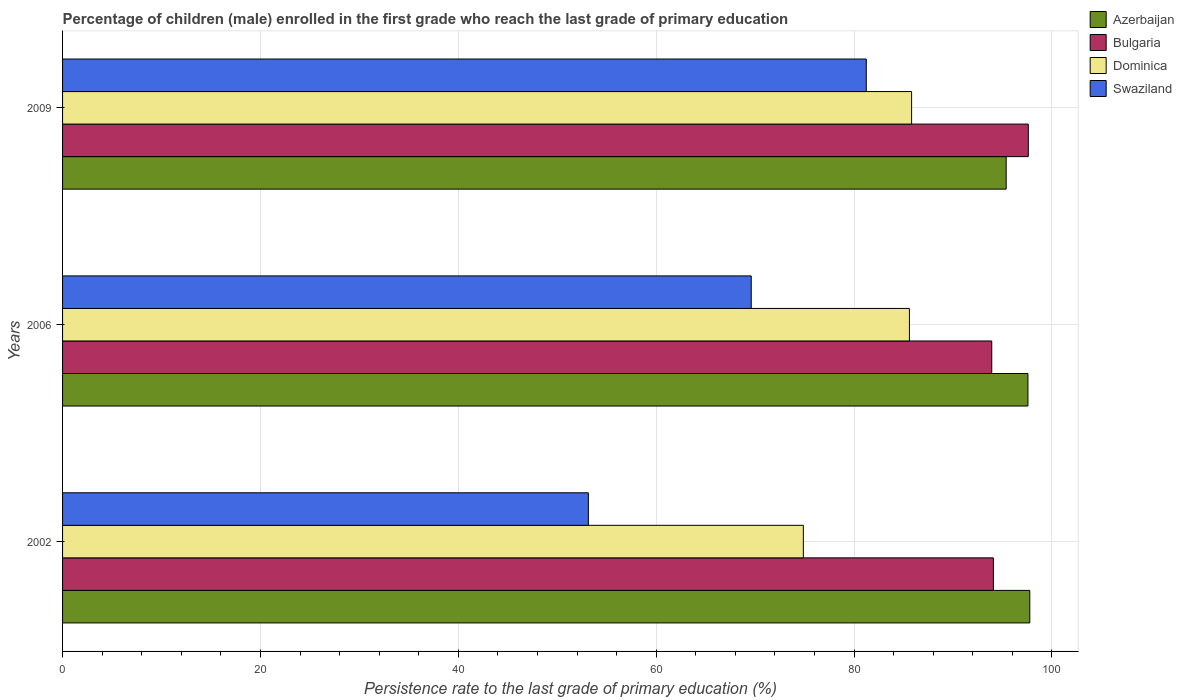How many different coloured bars are there?
Your answer should be very brief. 4. Are the number of bars on each tick of the Y-axis equal?
Make the answer very short. Yes. How many bars are there on the 2nd tick from the bottom?
Provide a succinct answer. 4. In how many cases, is the number of bars for a given year not equal to the number of legend labels?
Make the answer very short. 0. What is the persistence rate of children in Dominica in 2002?
Give a very brief answer. 74.88. Across all years, what is the maximum persistence rate of children in Dominica?
Offer a terse response. 85.82. Across all years, what is the minimum persistence rate of children in Bulgaria?
Provide a short and direct response. 93.92. In which year was the persistence rate of children in Dominica minimum?
Your response must be concise. 2002. What is the total persistence rate of children in Swaziland in the graph?
Your answer should be compact. 204. What is the difference between the persistence rate of children in Bulgaria in 2006 and that in 2009?
Your answer should be very brief. -3.7. What is the difference between the persistence rate of children in Swaziland in 2006 and the persistence rate of children in Azerbaijan in 2002?
Your answer should be very brief. -28.16. What is the average persistence rate of children in Azerbaijan per year?
Give a very brief answer. 96.91. In the year 2002, what is the difference between the persistence rate of children in Swaziland and persistence rate of children in Bulgaria?
Keep it short and to the point. -40.94. In how many years, is the persistence rate of children in Swaziland greater than 64 %?
Make the answer very short. 2. What is the ratio of the persistence rate of children in Dominica in 2002 to that in 2009?
Give a very brief answer. 0.87. Is the persistence rate of children in Dominica in 2002 less than that in 2009?
Your answer should be compact. Yes. What is the difference between the highest and the second highest persistence rate of children in Bulgaria?
Make the answer very short. 3.53. What is the difference between the highest and the lowest persistence rate of children in Dominica?
Keep it short and to the point. 10.94. Is the sum of the persistence rate of children in Bulgaria in 2002 and 2009 greater than the maximum persistence rate of children in Swaziland across all years?
Your answer should be compact. Yes. Is it the case that in every year, the sum of the persistence rate of children in Swaziland and persistence rate of children in Azerbaijan is greater than the sum of persistence rate of children in Bulgaria and persistence rate of children in Dominica?
Your answer should be compact. No. What does the 1st bar from the top in 2006 represents?
Offer a very short reply. Swaziland. What does the 3rd bar from the bottom in 2002 represents?
Offer a very short reply. Dominica. How many bars are there?
Your response must be concise. 12. What is the difference between two consecutive major ticks on the X-axis?
Offer a terse response. 20. What is the title of the graph?
Give a very brief answer. Percentage of children (male) enrolled in the first grade who reach the last grade of primary education. What is the label or title of the X-axis?
Give a very brief answer. Persistence rate to the last grade of primary education (%). What is the label or title of the Y-axis?
Ensure brevity in your answer.  Years. What is the Persistence rate to the last grade of primary education (%) of Azerbaijan in 2002?
Keep it short and to the point. 97.77. What is the Persistence rate to the last grade of primary education (%) of Bulgaria in 2002?
Provide a succinct answer. 94.09. What is the Persistence rate to the last grade of primary education (%) in Dominica in 2002?
Ensure brevity in your answer.  74.88. What is the Persistence rate to the last grade of primary education (%) in Swaziland in 2002?
Your answer should be compact. 53.15. What is the Persistence rate to the last grade of primary education (%) of Azerbaijan in 2006?
Your answer should be compact. 97.58. What is the Persistence rate to the last grade of primary education (%) of Bulgaria in 2006?
Your answer should be compact. 93.92. What is the Persistence rate to the last grade of primary education (%) of Dominica in 2006?
Offer a terse response. 85.6. What is the Persistence rate to the last grade of primary education (%) in Swaziland in 2006?
Give a very brief answer. 69.61. What is the Persistence rate to the last grade of primary education (%) in Azerbaijan in 2009?
Offer a very short reply. 95.38. What is the Persistence rate to the last grade of primary education (%) of Bulgaria in 2009?
Provide a succinct answer. 97.62. What is the Persistence rate to the last grade of primary education (%) of Dominica in 2009?
Your answer should be compact. 85.82. What is the Persistence rate to the last grade of primary education (%) in Swaziland in 2009?
Offer a terse response. 81.24. Across all years, what is the maximum Persistence rate to the last grade of primary education (%) in Azerbaijan?
Offer a very short reply. 97.77. Across all years, what is the maximum Persistence rate to the last grade of primary education (%) of Bulgaria?
Keep it short and to the point. 97.62. Across all years, what is the maximum Persistence rate to the last grade of primary education (%) in Dominica?
Provide a short and direct response. 85.82. Across all years, what is the maximum Persistence rate to the last grade of primary education (%) in Swaziland?
Your answer should be compact. 81.24. Across all years, what is the minimum Persistence rate to the last grade of primary education (%) of Azerbaijan?
Your response must be concise. 95.38. Across all years, what is the minimum Persistence rate to the last grade of primary education (%) in Bulgaria?
Provide a short and direct response. 93.92. Across all years, what is the minimum Persistence rate to the last grade of primary education (%) in Dominica?
Offer a terse response. 74.88. Across all years, what is the minimum Persistence rate to the last grade of primary education (%) in Swaziland?
Your response must be concise. 53.15. What is the total Persistence rate to the last grade of primary education (%) of Azerbaijan in the graph?
Ensure brevity in your answer.  290.73. What is the total Persistence rate to the last grade of primary education (%) of Bulgaria in the graph?
Provide a short and direct response. 285.62. What is the total Persistence rate to the last grade of primary education (%) in Dominica in the graph?
Your answer should be very brief. 246.3. What is the total Persistence rate to the last grade of primary education (%) of Swaziland in the graph?
Your answer should be compact. 204. What is the difference between the Persistence rate to the last grade of primary education (%) of Azerbaijan in 2002 and that in 2006?
Provide a succinct answer. 0.19. What is the difference between the Persistence rate to the last grade of primary education (%) in Bulgaria in 2002 and that in 2006?
Offer a terse response. 0.16. What is the difference between the Persistence rate to the last grade of primary education (%) in Dominica in 2002 and that in 2006?
Make the answer very short. -10.72. What is the difference between the Persistence rate to the last grade of primary education (%) in Swaziland in 2002 and that in 2006?
Provide a succinct answer. -16.46. What is the difference between the Persistence rate to the last grade of primary education (%) of Azerbaijan in 2002 and that in 2009?
Ensure brevity in your answer.  2.39. What is the difference between the Persistence rate to the last grade of primary education (%) in Bulgaria in 2002 and that in 2009?
Your answer should be very brief. -3.53. What is the difference between the Persistence rate to the last grade of primary education (%) of Dominica in 2002 and that in 2009?
Make the answer very short. -10.94. What is the difference between the Persistence rate to the last grade of primary education (%) of Swaziland in 2002 and that in 2009?
Give a very brief answer. -28.09. What is the difference between the Persistence rate to the last grade of primary education (%) in Azerbaijan in 2006 and that in 2009?
Make the answer very short. 2.2. What is the difference between the Persistence rate to the last grade of primary education (%) in Bulgaria in 2006 and that in 2009?
Your answer should be compact. -3.7. What is the difference between the Persistence rate to the last grade of primary education (%) in Dominica in 2006 and that in 2009?
Offer a very short reply. -0.22. What is the difference between the Persistence rate to the last grade of primary education (%) of Swaziland in 2006 and that in 2009?
Offer a very short reply. -11.63. What is the difference between the Persistence rate to the last grade of primary education (%) of Azerbaijan in 2002 and the Persistence rate to the last grade of primary education (%) of Bulgaria in 2006?
Your response must be concise. 3.85. What is the difference between the Persistence rate to the last grade of primary education (%) in Azerbaijan in 2002 and the Persistence rate to the last grade of primary education (%) in Dominica in 2006?
Ensure brevity in your answer.  12.17. What is the difference between the Persistence rate to the last grade of primary education (%) in Azerbaijan in 2002 and the Persistence rate to the last grade of primary education (%) in Swaziland in 2006?
Offer a terse response. 28.16. What is the difference between the Persistence rate to the last grade of primary education (%) of Bulgaria in 2002 and the Persistence rate to the last grade of primary education (%) of Dominica in 2006?
Offer a terse response. 8.49. What is the difference between the Persistence rate to the last grade of primary education (%) of Bulgaria in 2002 and the Persistence rate to the last grade of primary education (%) of Swaziland in 2006?
Offer a very short reply. 24.48. What is the difference between the Persistence rate to the last grade of primary education (%) in Dominica in 2002 and the Persistence rate to the last grade of primary education (%) in Swaziland in 2006?
Your response must be concise. 5.27. What is the difference between the Persistence rate to the last grade of primary education (%) in Azerbaijan in 2002 and the Persistence rate to the last grade of primary education (%) in Bulgaria in 2009?
Give a very brief answer. 0.15. What is the difference between the Persistence rate to the last grade of primary education (%) of Azerbaijan in 2002 and the Persistence rate to the last grade of primary education (%) of Dominica in 2009?
Your answer should be very brief. 11.95. What is the difference between the Persistence rate to the last grade of primary education (%) in Azerbaijan in 2002 and the Persistence rate to the last grade of primary education (%) in Swaziland in 2009?
Your answer should be very brief. 16.53. What is the difference between the Persistence rate to the last grade of primary education (%) of Bulgaria in 2002 and the Persistence rate to the last grade of primary education (%) of Dominica in 2009?
Your answer should be very brief. 8.27. What is the difference between the Persistence rate to the last grade of primary education (%) in Bulgaria in 2002 and the Persistence rate to the last grade of primary education (%) in Swaziland in 2009?
Your response must be concise. 12.85. What is the difference between the Persistence rate to the last grade of primary education (%) in Dominica in 2002 and the Persistence rate to the last grade of primary education (%) in Swaziland in 2009?
Your answer should be very brief. -6.36. What is the difference between the Persistence rate to the last grade of primary education (%) in Azerbaijan in 2006 and the Persistence rate to the last grade of primary education (%) in Bulgaria in 2009?
Provide a short and direct response. -0.04. What is the difference between the Persistence rate to the last grade of primary education (%) of Azerbaijan in 2006 and the Persistence rate to the last grade of primary education (%) of Dominica in 2009?
Offer a terse response. 11.76. What is the difference between the Persistence rate to the last grade of primary education (%) of Azerbaijan in 2006 and the Persistence rate to the last grade of primary education (%) of Swaziland in 2009?
Give a very brief answer. 16.34. What is the difference between the Persistence rate to the last grade of primary education (%) of Bulgaria in 2006 and the Persistence rate to the last grade of primary education (%) of Dominica in 2009?
Ensure brevity in your answer.  8.1. What is the difference between the Persistence rate to the last grade of primary education (%) in Bulgaria in 2006 and the Persistence rate to the last grade of primary education (%) in Swaziland in 2009?
Your response must be concise. 12.68. What is the difference between the Persistence rate to the last grade of primary education (%) of Dominica in 2006 and the Persistence rate to the last grade of primary education (%) of Swaziland in 2009?
Your answer should be very brief. 4.36. What is the average Persistence rate to the last grade of primary education (%) of Azerbaijan per year?
Your answer should be compact. 96.91. What is the average Persistence rate to the last grade of primary education (%) of Bulgaria per year?
Provide a short and direct response. 95.21. What is the average Persistence rate to the last grade of primary education (%) in Dominica per year?
Provide a succinct answer. 82.1. What is the average Persistence rate to the last grade of primary education (%) in Swaziland per year?
Provide a succinct answer. 68. In the year 2002, what is the difference between the Persistence rate to the last grade of primary education (%) of Azerbaijan and Persistence rate to the last grade of primary education (%) of Bulgaria?
Keep it short and to the point. 3.68. In the year 2002, what is the difference between the Persistence rate to the last grade of primary education (%) in Azerbaijan and Persistence rate to the last grade of primary education (%) in Dominica?
Give a very brief answer. 22.89. In the year 2002, what is the difference between the Persistence rate to the last grade of primary education (%) in Azerbaijan and Persistence rate to the last grade of primary education (%) in Swaziland?
Ensure brevity in your answer.  44.62. In the year 2002, what is the difference between the Persistence rate to the last grade of primary education (%) in Bulgaria and Persistence rate to the last grade of primary education (%) in Dominica?
Make the answer very short. 19.21. In the year 2002, what is the difference between the Persistence rate to the last grade of primary education (%) in Bulgaria and Persistence rate to the last grade of primary education (%) in Swaziland?
Provide a succinct answer. 40.94. In the year 2002, what is the difference between the Persistence rate to the last grade of primary education (%) of Dominica and Persistence rate to the last grade of primary education (%) of Swaziland?
Offer a very short reply. 21.73. In the year 2006, what is the difference between the Persistence rate to the last grade of primary education (%) in Azerbaijan and Persistence rate to the last grade of primary education (%) in Bulgaria?
Give a very brief answer. 3.66. In the year 2006, what is the difference between the Persistence rate to the last grade of primary education (%) in Azerbaijan and Persistence rate to the last grade of primary education (%) in Dominica?
Offer a very short reply. 11.98. In the year 2006, what is the difference between the Persistence rate to the last grade of primary education (%) in Azerbaijan and Persistence rate to the last grade of primary education (%) in Swaziland?
Provide a succinct answer. 27.97. In the year 2006, what is the difference between the Persistence rate to the last grade of primary education (%) in Bulgaria and Persistence rate to the last grade of primary education (%) in Dominica?
Keep it short and to the point. 8.32. In the year 2006, what is the difference between the Persistence rate to the last grade of primary education (%) of Bulgaria and Persistence rate to the last grade of primary education (%) of Swaziland?
Provide a succinct answer. 24.31. In the year 2006, what is the difference between the Persistence rate to the last grade of primary education (%) in Dominica and Persistence rate to the last grade of primary education (%) in Swaziland?
Provide a succinct answer. 15.99. In the year 2009, what is the difference between the Persistence rate to the last grade of primary education (%) in Azerbaijan and Persistence rate to the last grade of primary education (%) in Bulgaria?
Keep it short and to the point. -2.24. In the year 2009, what is the difference between the Persistence rate to the last grade of primary education (%) of Azerbaijan and Persistence rate to the last grade of primary education (%) of Dominica?
Ensure brevity in your answer.  9.56. In the year 2009, what is the difference between the Persistence rate to the last grade of primary education (%) of Azerbaijan and Persistence rate to the last grade of primary education (%) of Swaziland?
Offer a terse response. 14.14. In the year 2009, what is the difference between the Persistence rate to the last grade of primary education (%) of Bulgaria and Persistence rate to the last grade of primary education (%) of Dominica?
Your answer should be compact. 11.8. In the year 2009, what is the difference between the Persistence rate to the last grade of primary education (%) in Bulgaria and Persistence rate to the last grade of primary education (%) in Swaziland?
Give a very brief answer. 16.38. In the year 2009, what is the difference between the Persistence rate to the last grade of primary education (%) in Dominica and Persistence rate to the last grade of primary education (%) in Swaziland?
Provide a short and direct response. 4.58. What is the ratio of the Persistence rate to the last grade of primary education (%) in Azerbaijan in 2002 to that in 2006?
Your answer should be very brief. 1. What is the ratio of the Persistence rate to the last grade of primary education (%) in Bulgaria in 2002 to that in 2006?
Offer a very short reply. 1. What is the ratio of the Persistence rate to the last grade of primary education (%) in Dominica in 2002 to that in 2006?
Make the answer very short. 0.87. What is the ratio of the Persistence rate to the last grade of primary education (%) of Swaziland in 2002 to that in 2006?
Provide a short and direct response. 0.76. What is the ratio of the Persistence rate to the last grade of primary education (%) in Azerbaijan in 2002 to that in 2009?
Offer a very short reply. 1.02. What is the ratio of the Persistence rate to the last grade of primary education (%) in Bulgaria in 2002 to that in 2009?
Keep it short and to the point. 0.96. What is the ratio of the Persistence rate to the last grade of primary education (%) of Dominica in 2002 to that in 2009?
Your answer should be very brief. 0.87. What is the ratio of the Persistence rate to the last grade of primary education (%) in Swaziland in 2002 to that in 2009?
Ensure brevity in your answer.  0.65. What is the ratio of the Persistence rate to the last grade of primary education (%) in Azerbaijan in 2006 to that in 2009?
Give a very brief answer. 1.02. What is the ratio of the Persistence rate to the last grade of primary education (%) in Bulgaria in 2006 to that in 2009?
Give a very brief answer. 0.96. What is the ratio of the Persistence rate to the last grade of primary education (%) in Swaziland in 2006 to that in 2009?
Your answer should be compact. 0.86. What is the difference between the highest and the second highest Persistence rate to the last grade of primary education (%) of Azerbaijan?
Give a very brief answer. 0.19. What is the difference between the highest and the second highest Persistence rate to the last grade of primary education (%) in Bulgaria?
Provide a short and direct response. 3.53. What is the difference between the highest and the second highest Persistence rate to the last grade of primary education (%) of Dominica?
Your answer should be compact. 0.22. What is the difference between the highest and the second highest Persistence rate to the last grade of primary education (%) of Swaziland?
Your answer should be compact. 11.63. What is the difference between the highest and the lowest Persistence rate to the last grade of primary education (%) of Azerbaijan?
Your response must be concise. 2.39. What is the difference between the highest and the lowest Persistence rate to the last grade of primary education (%) of Bulgaria?
Keep it short and to the point. 3.7. What is the difference between the highest and the lowest Persistence rate to the last grade of primary education (%) of Dominica?
Offer a terse response. 10.94. What is the difference between the highest and the lowest Persistence rate to the last grade of primary education (%) of Swaziland?
Offer a very short reply. 28.09. 